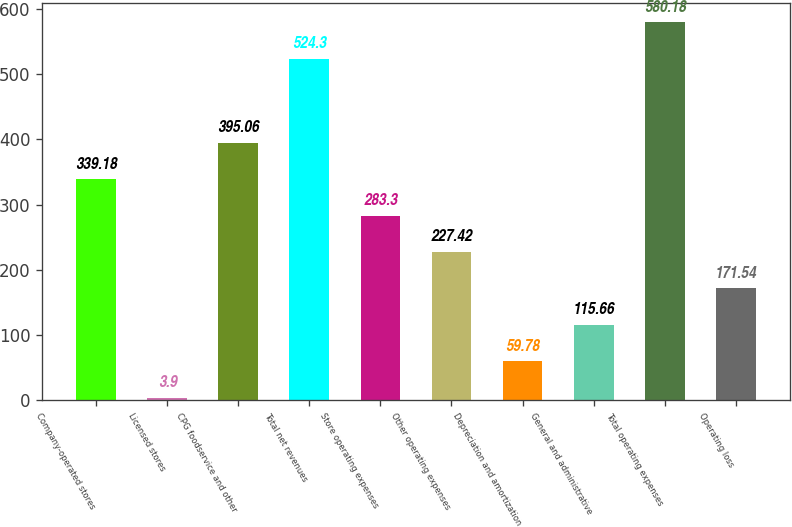<chart> <loc_0><loc_0><loc_500><loc_500><bar_chart><fcel>Company-operated stores<fcel>Licensed stores<fcel>CPG foodservice and other<fcel>Total net revenues<fcel>Store operating expenses<fcel>Other operating expenses<fcel>Depreciation and amortization<fcel>General and administrative<fcel>Total operating expenses<fcel>Operating loss<nl><fcel>339.18<fcel>3.9<fcel>395.06<fcel>524.3<fcel>283.3<fcel>227.42<fcel>59.78<fcel>115.66<fcel>580.18<fcel>171.54<nl></chart> 